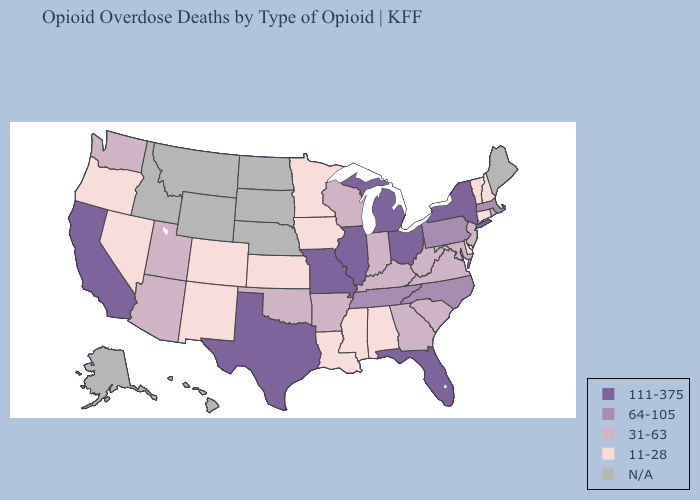Does Louisiana have the highest value in the USA?
Keep it brief. No. Which states hav the highest value in the Northeast?
Concise answer only. New York. Which states hav the highest value in the South?
Keep it brief. Florida, Texas. Name the states that have a value in the range 111-375?
Give a very brief answer. California, Florida, Illinois, Michigan, Missouri, New York, Ohio, Texas. What is the lowest value in the South?
Concise answer only. 11-28. What is the value of Illinois?
Write a very short answer. 111-375. Among the states that border Tennessee , does Missouri have the highest value?
Quick response, please. Yes. How many symbols are there in the legend?
Keep it brief. 5. Among the states that border South Carolina , does Georgia have the highest value?
Keep it brief. No. Is the legend a continuous bar?
Keep it brief. No. What is the value of Maryland?
Concise answer only. 31-63. What is the lowest value in the USA?
Keep it brief. 11-28. What is the value of Nebraska?
Quick response, please. N/A. Does Vermont have the lowest value in the USA?
Keep it brief. Yes. 